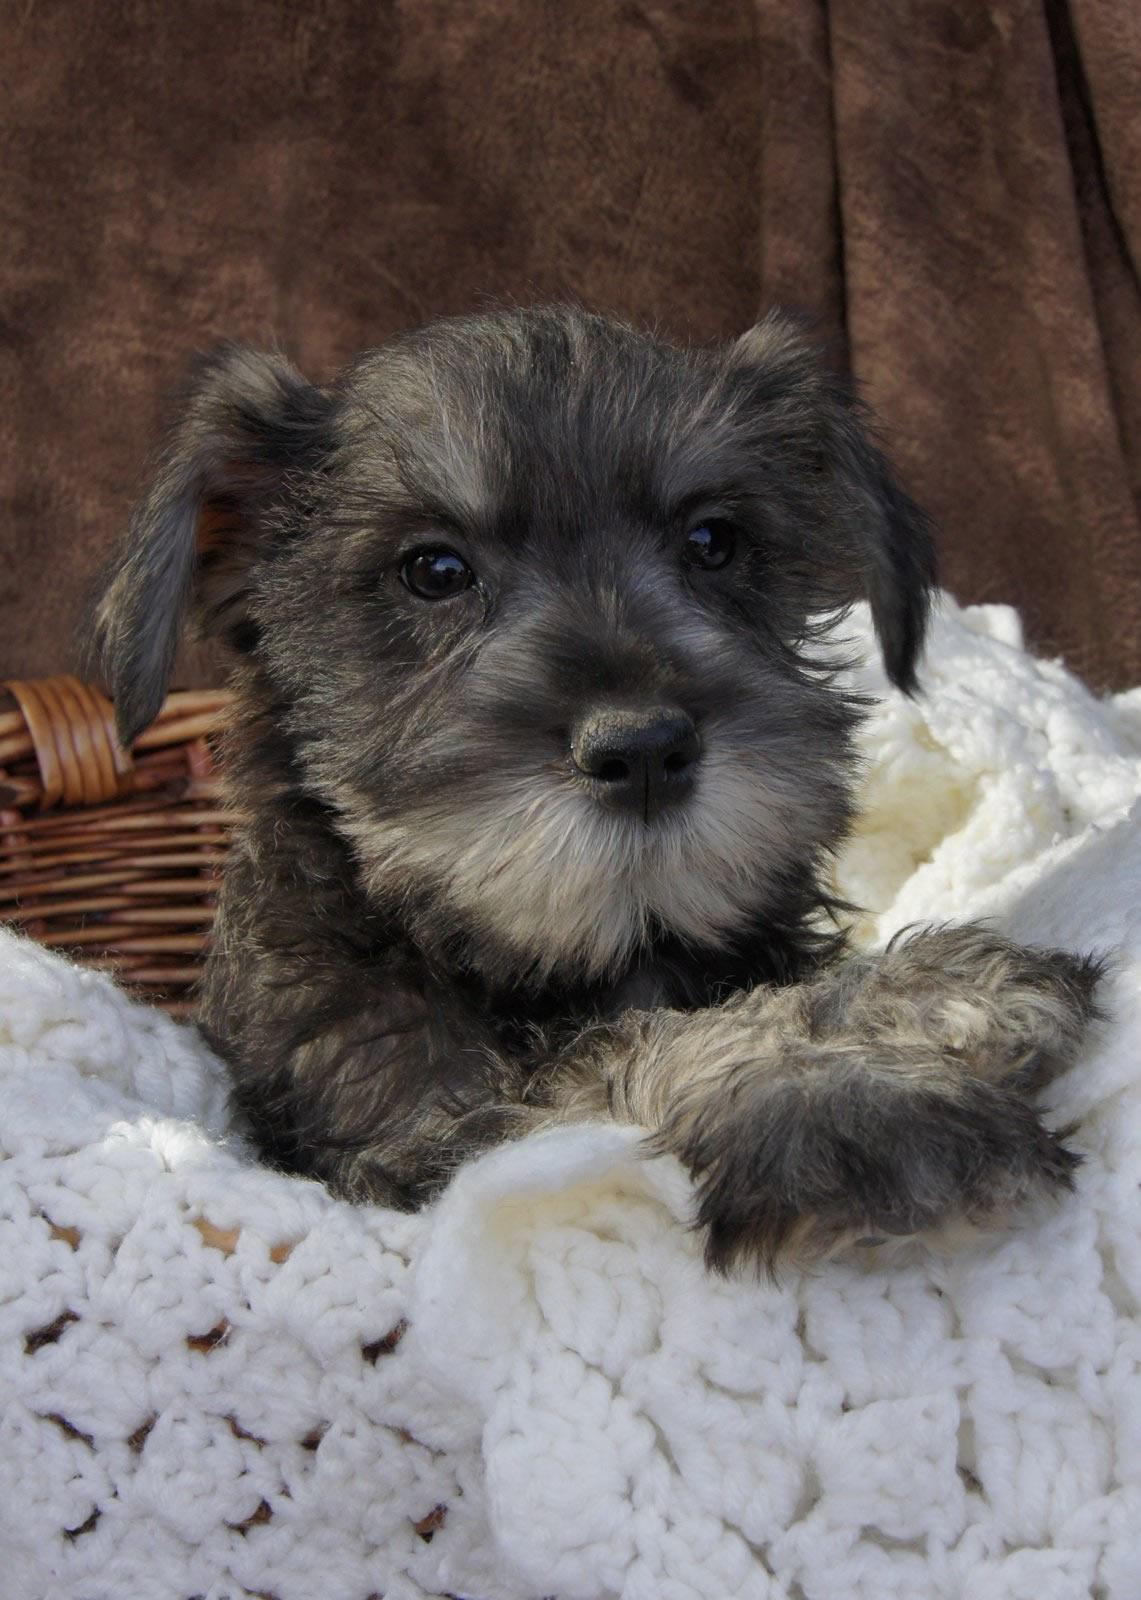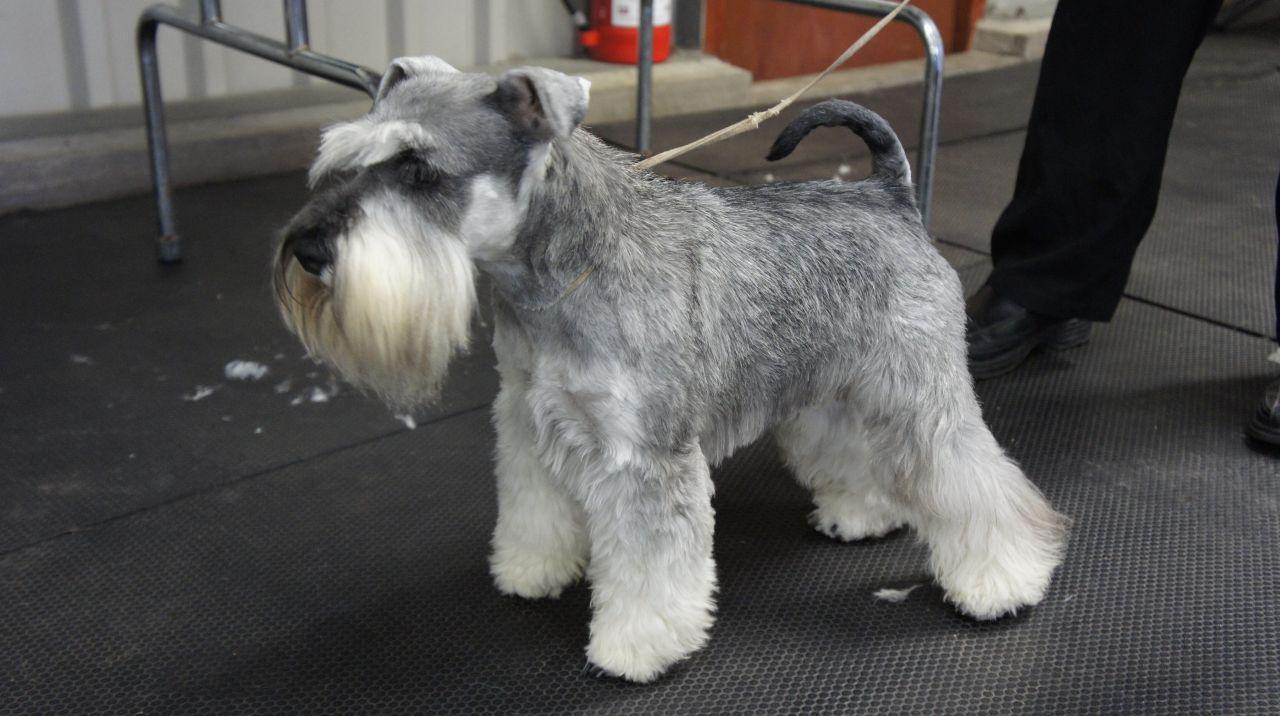The first image is the image on the left, the second image is the image on the right. Considering the images on both sides, is "In one of the images there is a dog on a leash." valid? Answer yes or no. Yes. The first image is the image on the left, the second image is the image on the right. Given the left and right images, does the statement "The left image shows one schnauzer with its paws propped over and its head poking out of a container, which is draped with something white." hold true? Answer yes or no. Yes. 